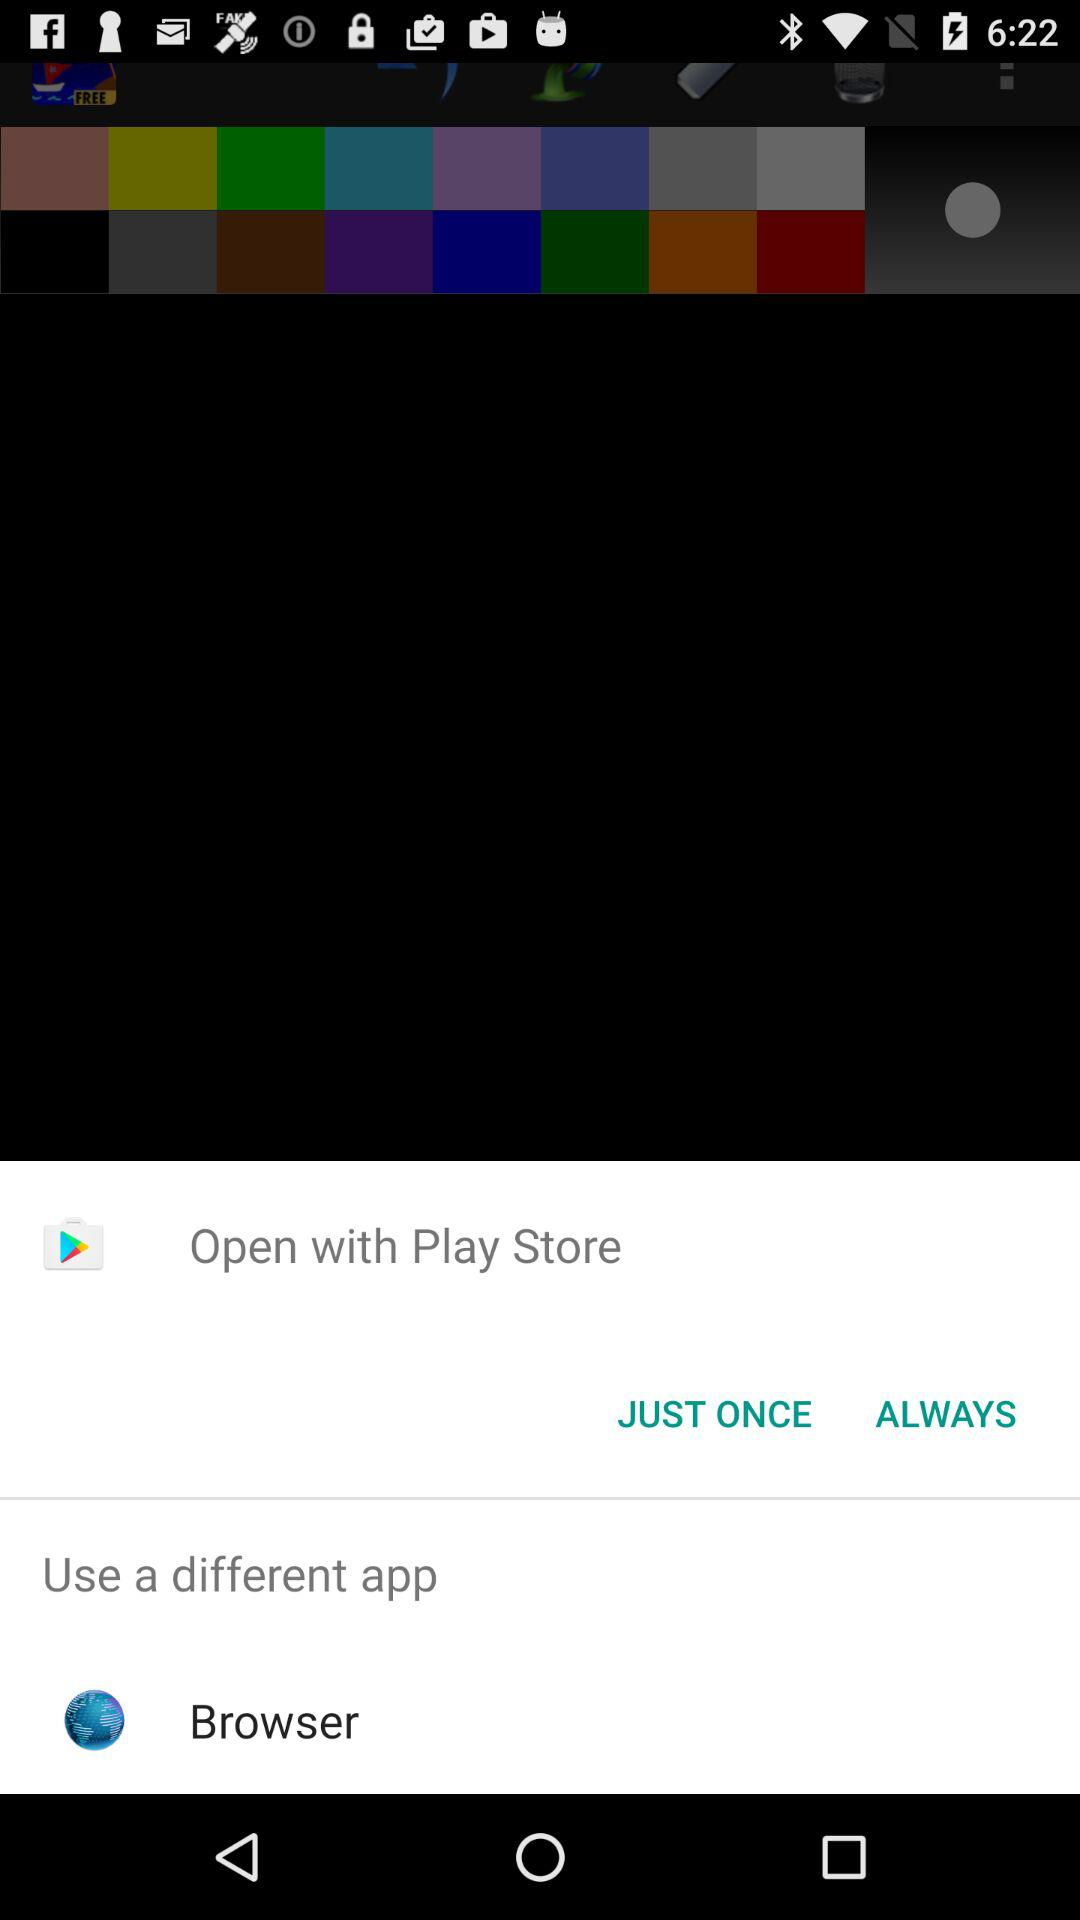Through which application can it be opened? It can be opened through "Play Store" and "Browser". 